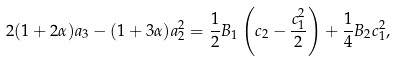<formula> <loc_0><loc_0><loc_500><loc_500>2 ( 1 + 2 \alpha ) a _ { 3 } - ( 1 + 3 \alpha ) a _ { 2 } ^ { 2 } = \frac { 1 } { 2 } B _ { 1 } \left ( c _ { 2 } - \frac { c _ { 1 } ^ { 2 } } { 2 } \right ) + \frac { 1 } { 4 } B _ { 2 } c _ { 1 } ^ { 2 } ,</formula> 